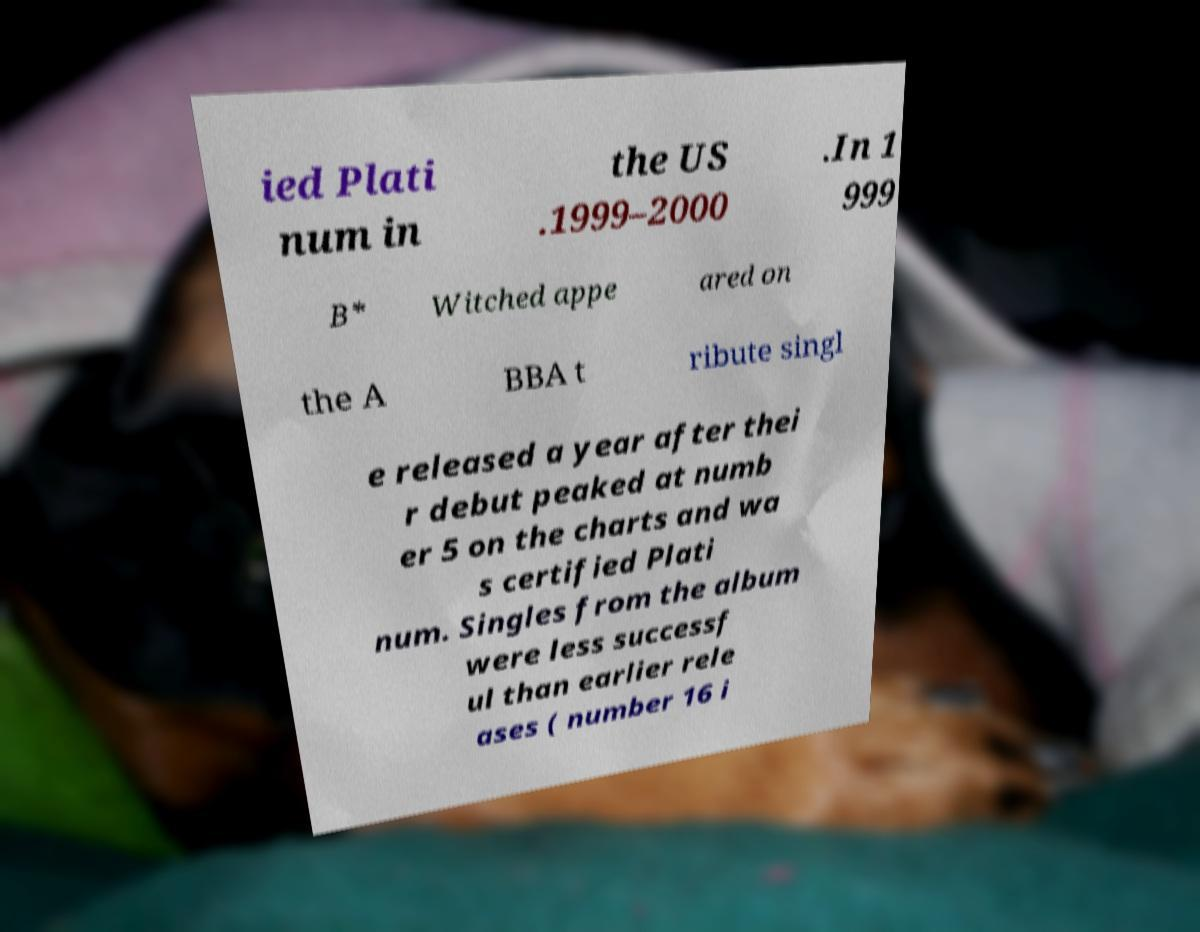I need the written content from this picture converted into text. Can you do that? ied Plati num in the US .1999–2000 .In 1 999 B* Witched appe ared on the A BBA t ribute singl e released a year after thei r debut peaked at numb er 5 on the charts and wa s certified Plati num. Singles from the album were less successf ul than earlier rele ases ( number 16 i 